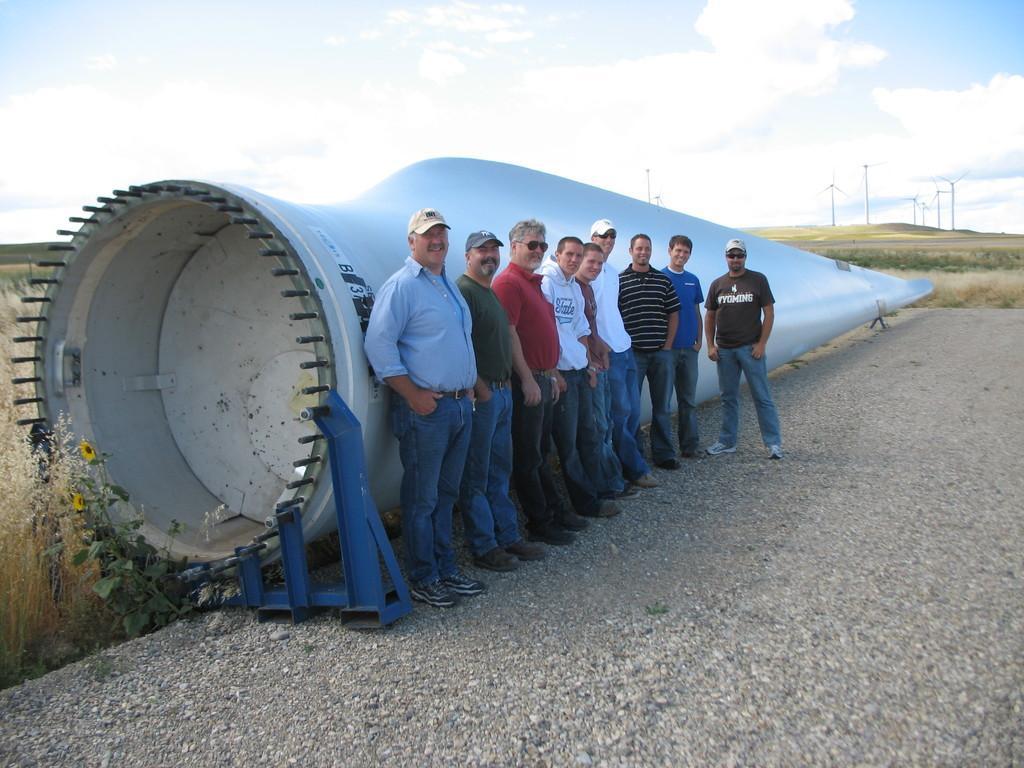Can you describe this image briefly? In the foreground of the picture there are people standing near a windmill. On the left there are plants and sunflower. In the foreground and towards right there are gravel stones. In the background there are plants, field and windmills. Sky is partially cloudy. 